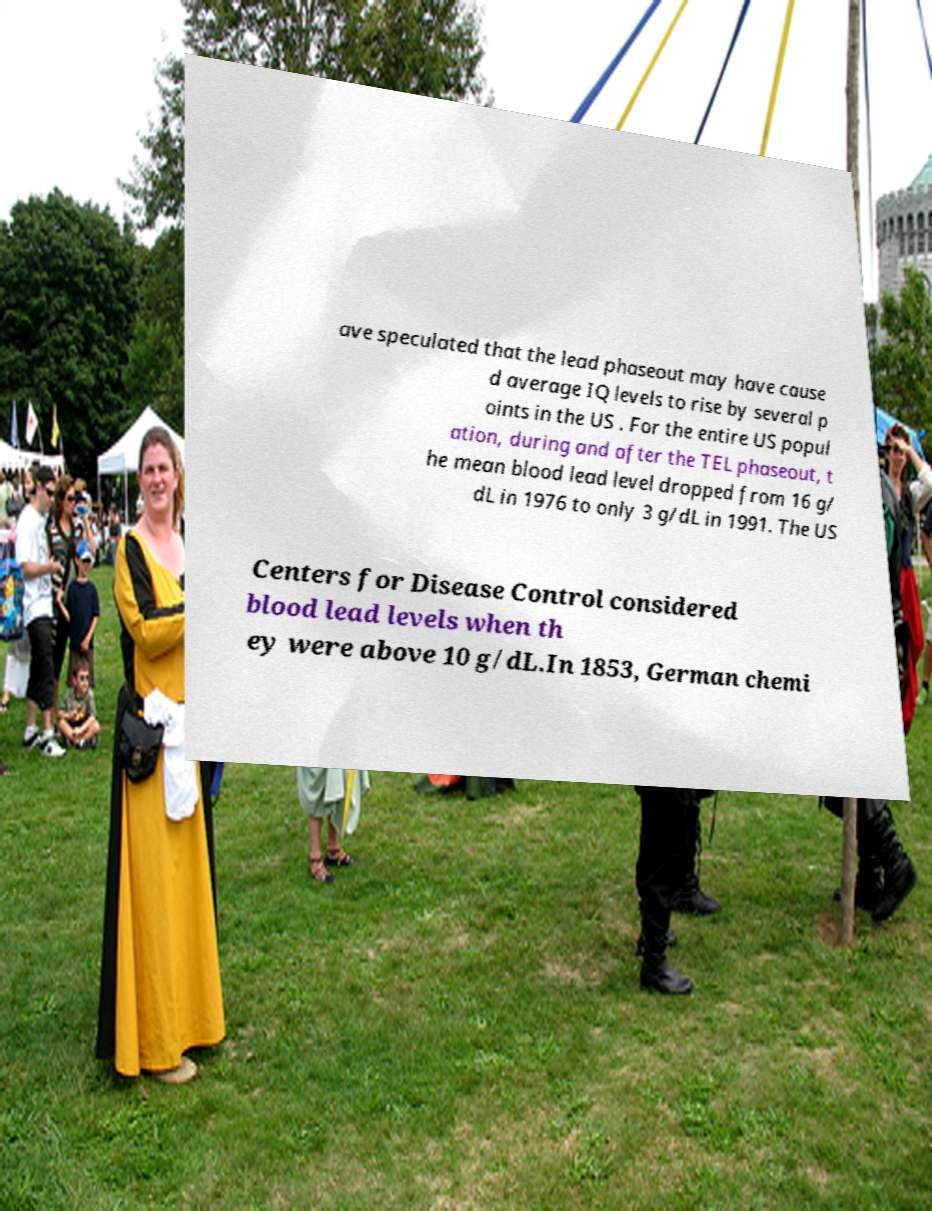Please read and relay the text visible in this image. What does it say? ave speculated that the lead phaseout may have cause d average IQ levels to rise by several p oints in the US . For the entire US popul ation, during and after the TEL phaseout, t he mean blood lead level dropped from 16 g/ dL in 1976 to only 3 g/dL in 1991. The US Centers for Disease Control considered blood lead levels when th ey were above 10 g/dL.In 1853, German chemi 